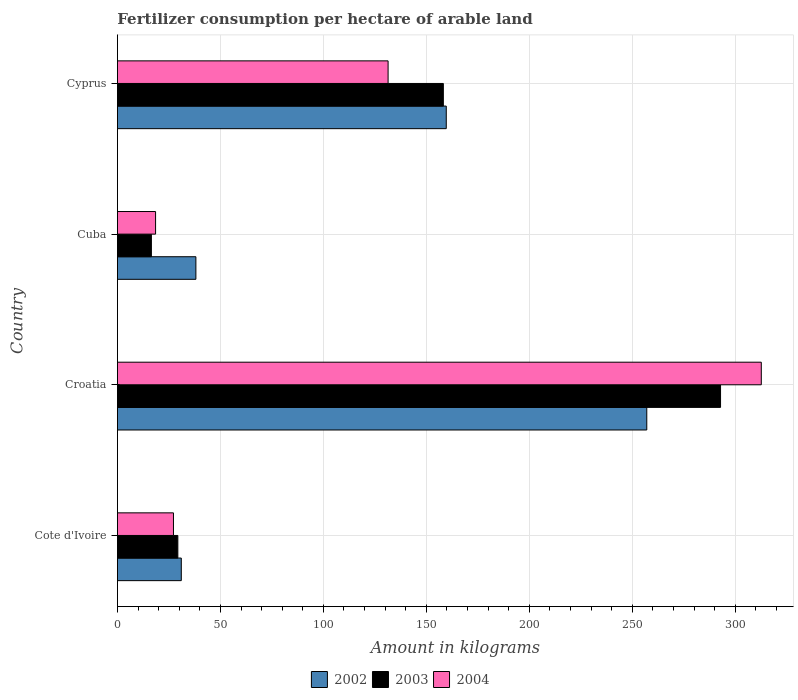How many groups of bars are there?
Provide a short and direct response. 4. How many bars are there on the 3rd tick from the top?
Offer a very short reply. 3. How many bars are there on the 3rd tick from the bottom?
Your answer should be very brief. 3. What is the label of the 3rd group of bars from the top?
Give a very brief answer. Croatia. What is the amount of fertilizer consumption in 2004 in Cuba?
Provide a succinct answer. 18.53. Across all countries, what is the maximum amount of fertilizer consumption in 2003?
Provide a short and direct response. 292.8. Across all countries, what is the minimum amount of fertilizer consumption in 2003?
Provide a succinct answer. 16.5. In which country was the amount of fertilizer consumption in 2004 maximum?
Ensure brevity in your answer.  Croatia. In which country was the amount of fertilizer consumption in 2004 minimum?
Your answer should be compact. Cuba. What is the total amount of fertilizer consumption in 2002 in the graph?
Offer a very short reply. 485.76. What is the difference between the amount of fertilizer consumption in 2002 in Croatia and that in Cuba?
Make the answer very short. 218.88. What is the difference between the amount of fertilizer consumption in 2003 in Croatia and the amount of fertilizer consumption in 2004 in Cyprus?
Keep it short and to the point. 161.4. What is the average amount of fertilizer consumption in 2004 per country?
Make the answer very short. 122.44. What is the difference between the amount of fertilizer consumption in 2004 and amount of fertilizer consumption in 2002 in Cote d'Ivoire?
Make the answer very short. -3.8. What is the ratio of the amount of fertilizer consumption in 2003 in Croatia to that in Cuba?
Your answer should be compact. 17.74. What is the difference between the highest and the second highest amount of fertilizer consumption in 2004?
Ensure brevity in your answer.  181.18. What is the difference between the highest and the lowest amount of fertilizer consumption in 2003?
Make the answer very short. 276.3. Is the sum of the amount of fertilizer consumption in 2003 in Croatia and Cyprus greater than the maximum amount of fertilizer consumption in 2004 across all countries?
Provide a succinct answer. Yes. What does the 2nd bar from the top in Cuba represents?
Your answer should be compact. 2003. How many bars are there?
Offer a very short reply. 12. What is the difference between two consecutive major ticks on the X-axis?
Offer a very short reply. 50. Are the values on the major ticks of X-axis written in scientific E-notation?
Provide a succinct answer. No. Where does the legend appear in the graph?
Your answer should be compact. Bottom center. What is the title of the graph?
Your answer should be very brief. Fertilizer consumption per hectare of arable land. Does "1982" appear as one of the legend labels in the graph?
Keep it short and to the point. No. What is the label or title of the X-axis?
Offer a terse response. Amount in kilograms. What is the label or title of the Y-axis?
Your answer should be very brief. Country. What is the Amount in kilograms of 2002 in Cote d'Ivoire?
Your answer should be very brief. 31.02. What is the Amount in kilograms of 2003 in Cote d'Ivoire?
Offer a terse response. 29.35. What is the Amount in kilograms of 2004 in Cote d'Ivoire?
Provide a succinct answer. 27.22. What is the Amount in kilograms in 2002 in Croatia?
Your answer should be compact. 256.99. What is the Amount in kilograms in 2003 in Croatia?
Offer a very short reply. 292.8. What is the Amount in kilograms of 2004 in Croatia?
Offer a terse response. 312.58. What is the Amount in kilograms of 2002 in Cuba?
Your response must be concise. 38.1. What is the Amount in kilograms of 2003 in Cuba?
Give a very brief answer. 16.5. What is the Amount in kilograms of 2004 in Cuba?
Offer a very short reply. 18.53. What is the Amount in kilograms of 2002 in Cyprus?
Offer a very short reply. 159.65. What is the Amount in kilograms in 2003 in Cyprus?
Give a very brief answer. 158.23. What is the Amount in kilograms of 2004 in Cyprus?
Keep it short and to the point. 131.41. Across all countries, what is the maximum Amount in kilograms of 2002?
Keep it short and to the point. 256.99. Across all countries, what is the maximum Amount in kilograms in 2003?
Offer a terse response. 292.8. Across all countries, what is the maximum Amount in kilograms in 2004?
Your response must be concise. 312.58. Across all countries, what is the minimum Amount in kilograms in 2002?
Make the answer very short. 31.02. Across all countries, what is the minimum Amount in kilograms in 2003?
Provide a short and direct response. 16.5. Across all countries, what is the minimum Amount in kilograms in 2004?
Offer a terse response. 18.53. What is the total Amount in kilograms in 2002 in the graph?
Provide a short and direct response. 485.76. What is the total Amount in kilograms of 2003 in the graph?
Make the answer very short. 496.88. What is the total Amount in kilograms of 2004 in the graph?
Make the answer very short. 489.74. What is the difference between the Amount in kilograms of 2002 in Cote d'Ivoire and that in Croatia?
Ensure brevity in your answer.  -225.97. What is the difference between the Amount in kilograms in 2003 in Cote d'Ivoire and that in Croatia?
Offer a very short reply. -263.46. What is the difference between the Amount in kilograms of 2004 in Cote d'Ivoire and that in Croatia?
Offer a very short reply. -285.37. What is the difference between the Amount in kilograms of 2002 in Cote d'Ivoire and that in Cuba?
Your response must be concise. -7.09. What is the difference between the Amount in kilograms of 2003 in Cote d'Ivoire and that in Cuba?
Provide a succinct answer. 12.84. What is the difference between the Amount in kilograms of 2004 in Cote d'Ivoire and that in Cuba?
Keep it short and to the point. 8.69. What is the difference between the Amount in kilograms of 2002 in Cote d'Ivoire and that in Cyprus?
Provide a succinct answer. -128.63. What is the difference between the Amount in kilograms in 2003 in Cote d'Ivoire and that in Cyprus?
Your answer should be compact. -128.89. What is the difference between the Amount in kilograms in 2004 in Cote d'Ivoire and that in Cyprus?
Your answer should be very brief. -104.19. What is the difference between the Amount in kilograms of 2002 in Croatia and that in Cuba?
Your response must be concise. 218.88. What is the difference between the Amount in kilograms of 2003 in Croatia and that in Cuba?
Provide a succinct answer. 276.3. What is the difference between the Amount in kilograms of 2004 in Croatia and that in Cuba?
Offer a terse response. 294.05. What is the difference between the Amount in kilograms in 2002 in Croatia and that in Cyprus?
Give a very brief answer. 97.34. What is the difference between the Amount in kilograms in 2003 in Croatia and that in Cyprus?
Your answer should be very brief. 134.57. What is the difference between the Amount in kilograms in 2004 in Croatia and that in Cyprus?
Your answer should be very brief. 181.18. What is the difference between the Amount in kilograms of 2002 in Cuba and that in Cyprus?
Provide a short and direct response. -121.55. What is the difference between the Amount in kilograms of 2003 in Cuba and that in Cyprus?
Your answer should be compact. -141.73. What is the difference between the Amount in kilograms of 2004 in Cuba and that in Cyprus?
Keep it short and to the point. -112.88. What is the difference between the Amount in kilograms of 2002 in Cote d'Ivoire and the Amount in kilograms of 2003 in Croatia?
Provide a succinct answer. -261.78. What is the difference between the Amount in kilograms of 2002 in Cote d'Ivoire and the Amount in kilograms of 2004 in Croatia?
Make the answer very short. -281.57. What is the difference between the Amount in kilograms in 2003 in Cote d'Ivoire and the Amount in kilograms in 2004 in Croatia?
Provide a succinct answer. -283.24. What is the difference between the Amount in kilograms of 2002 in Cote d'Ivoire and the Amount in kilograms of 2003 in Cuba?
Give a very brief answer. 14.52. What is the difference between the Amount in kilograms in 2002 in Cote d'Ivoire and the Amount in kilograms in 2004 in Cuba?
Offer a very short reply. 12.49. What is the difference between the Amount in kilograms of 2003 in Cote d'Ivoire and the Amount in kilograms of 2004 in Cuba?
Your response must be concise. 10.82. What is the difference between the Amount in kilograms of 2002 in Cote d'Ivoire and the Amount in kilograms of 2003 in Cyprus?
Give a very brief answer. -127.21. What is the difference between the Amount in kilograms in 2002 in Cote d'Ivoire and the Amount in kilograms in 2004 in Cyprus?
Your answer should be compact. -100.39. What is the difference between the Amount in kilograms in 2003 in Cote d'Ivoire and the Amount in kilograms in 2004 in Cyprus?
Provide a short and direct response. -102.06. What is the difference between the Amount in kilograms of 2002 in Croatia and the Amount in kilograms of 2003 in Cuba?
Give a very brief answer. 240.49. What is the difference between the Amount in kilograms of 2002 in Croatia and the Amount in kilograms of 2004 in Cuba?
Provide a short and direct response. 238.46. What is the difference between the Amount in kilograms in 2003 in Croatia and the Amount in kilograms in 2004 in Cuba?
Your response must be concise. 274.27. What is the difference between the Amount in kilograms of 2002 in Croatia and the Amount in kilograms of 2003 in Cyprus?
Your answer should be compact. 98.76. What is the difference between the Amount in kilograms in 2002 in Croatia and the Amount in kilograms in 2004 in Cyprus?
Your answer should be compact. 125.58. What is the difference between the Amount in kilograms in 2003 in Croatia and the Amount in kilograms in 2004 in Cyprus?
Your answer should be compact. 161.4. What is the difference between the Amount in kilograms of 2002 in Cuba and the Amount in kilograms of 2003 in Cyprus?
Ensure brevity in your answer.  -120.13. What is the difference between the Amount in kilograms of 2002 in Cuba and the Amount in kilograms of 2004 in Cyprus?
Offer a very short reply. -93.3. What is the difference between the Amount in kilograms of 2003 in Cuba and the Amount in kilograms of 2004 in Cyprus?
Ensure brevity in your answer.  -114.9. What is the average Amount in kilograms of 2002 per country?
Your response must be concise. 121.44. What is the average Amount in kilograms of 2003 per country?
Make the answer very short. 124.22. What is the average Amount in kilograms in 2004 per country?
Your answer should be very brief. 122.44. What is the difference between the Amount in kilograms of 2002 and Amount in kilograms of 2003 in Cote d'Ivoire?
Give a very brief answer. 1.67. What is the difference between the Amount in kilograms in 2003 and Amount in kilograms in 2004 in Cote d'Ivoire?
Offer a terse response. 2.13. What is the difference between the Amount in kilograms in 2002 and Amount in kilograms in 2003 in Croatia?
Offer a terse response. -35.81. What is the difference between the Amount in kilograms of 2002 and Amount in kilograms of 2004 in Croatia?
Ensure brevity in your answer.  -55.6. What is the difference between the Amount in kilograms of 2003 and Amount in kilograms of 2004 in Croatia?
Your answer should be compact. -19.78. What is the difference between the Amount in kilograms of 2002 and Amount in kilograms of 2003 in Cuba?
Offer a very short reply. 21.6. What is the difference between the Amount in kilograms in 2002 and Amount in kilograms in 2004 in Cuba?
Your answer should be very brief. 19.57. What is the difference between the Amount in kilograms of 2003 and Amount in kilograms of 2004 in Cuba?
Your response must be concise. -2.03. What is the difference between the Amount in kilograms of 2002 and Amount in kilograms of 2003 in Cyprus?
Offer a very short reply. 1.42. What is the difference between the Amount in kilograms in 2002 and Amount in kilograms in 2004 in Cyprus?
Ensure brevity in your answer.  28.24. What is the difference between the Amount in kilograms of 2003 and Amount in kilograms of 2004 in Cyprus?
Ensure brevity in your answer.  26.83. What is the ratio of the Amount in kilograms of 2002 in Cote d'Ivoire to that in Croatia?
Provide a succinct answer. 0.12. What is the ratio of the Amount in kilograms of 2003 in Cote d'Ivoire to that in Croatia?
Your answer should be compact. 0.1. What is the ratio of the Amount in kilograms of 2004 in Cote d'Ivoire to that in Croatia?
Offer a terse response. 0.09. What is the ratio of the Amount in kilograms of 2002 in Cote d'Ivoire to that in Cuba?
Your response must be concise. 0.81. What is the ratio of the Amount in kilograms in 2003 in Cote d'Ivoire to that in Cuba?
Your answer should be compact. 1.78. What is the ratio of the Amount in kilograms in 2004 in Cote d'Ivoire to that in Cuba?
Ensure brevity in your answer.  1.47. What is the ratio of the Amount in kilograms of 2002 in Cote d'Ivoire to that in Cyprus?
Provide a succinct answer. 0.19. What is the ratio of the Amount in kilograms in 2003 in Cote d'Ivoire to that in Cyprus?
Keep it short and to the point. 0.19. What is the ratio of the Amount in kilograms in 2004 in Cote d'Ivoire to that in Cyprus?
Your response must be concise. 0.21. What is the ratio of the Amount in kilograms in 2002 in Croatia to that in Cuba?
Give a very brief answer. 6.74. What is the ratio of the Amount in kilograms in 2003 in Croatia to that in Cuba?
Provide a succinct answer. 17.74. What is the ratio of the Amount in kilograms in 2004 in Croatia to that in Cuba?
Provide a short and direct response. 16.87. What is the ratio of the Amount in kilograms of 2002 in Croatia to that in Cyprus?
Offer a terse response. 1.61. What is the ratio of the Amount in kilograms in 2003 in Croatia to that in Cyprus?
Provide a short and direct response. 1.85. What is the ratio of the Amount in kilograms of 2004 in Croatia to that in Cyprus?
Your answer should be very brief. 2.38. What is the ratio of the Amount in kilograms of 2002 in Cuba to that in Cyprus?
Make the answer very short. 0.24. What is the ratio of the Amount in kilograms in 2003 in Cuba to that in Cyprus?
Provide a succinct answer. 0.1. What is the ratio of the Amount in kilograms of 2004 in Cuba to that in Cyprus?
Your answer should be compact. 0.14. What is the difference between the highest and the second highest Amount in kilograms in 2002?
Provide a succinct answer. 97.34. What is the difference between the highest and the second highest Amount in kilograms of 2003?
Your answer should be compact. 134.57. What is the difference between the highest and the second highest Amount in kilograms of 2004?
Keep it short and to the point. 181.18. What is the difference between the highest and the lowest Amount in kilograms of 2002?
Your answer should be very brief. 225.97. What is the difference between the highest and the lowest Amount in kilograms of 2003?
Offer a very short reply. 276.3. What is the difference between the highest and the lowest Amount in kilograms of 2004?
Provide a short and direct response. 294.05. 